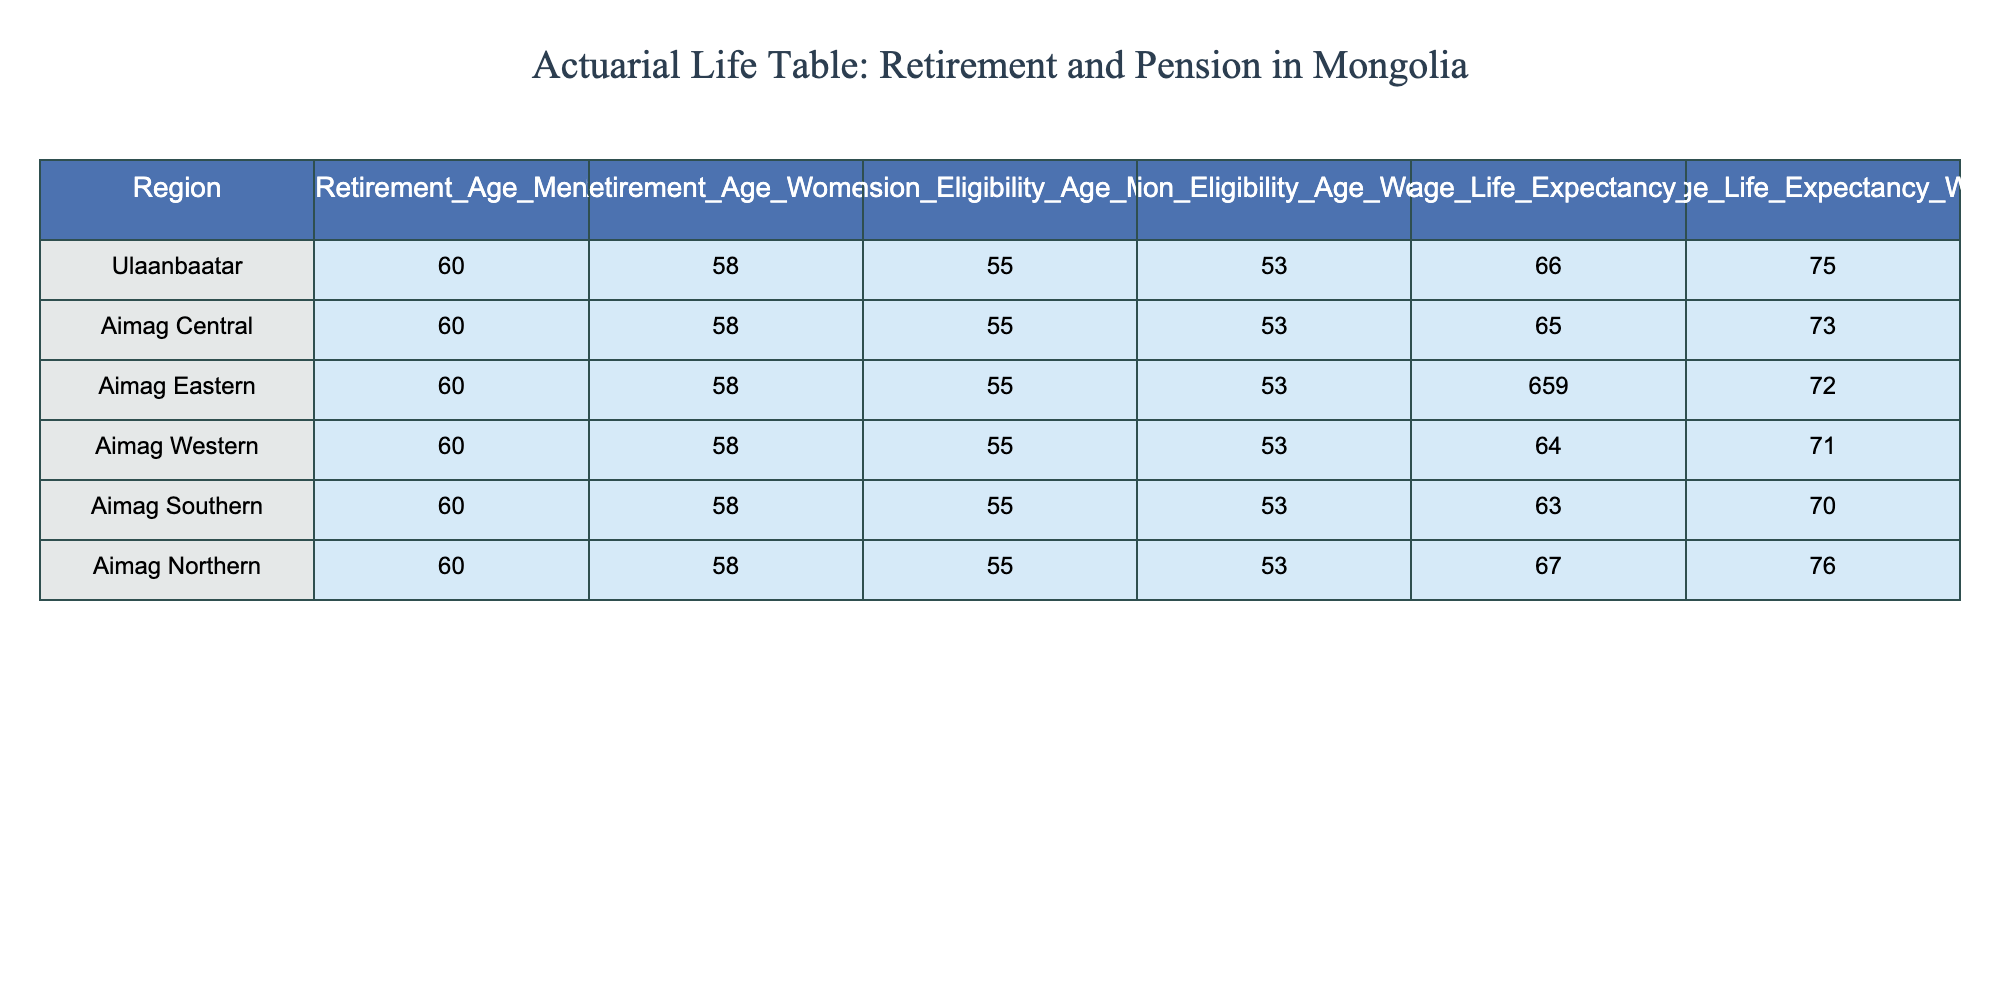What is the retirement age for men in Ulaanbaatar? According to the table, the retirement age for men in Ulaanbaatar is listed directly under the "Retirement_Age_Men" column, which is 60 years.
Answer: 60 What is the pension eligibility age for women in Aimag Central? The pension eligibility age for women in Aimag Central can be found in the "Pension_Eligibility_Age_Women" column for that region, which is 53 years.
Answer: 53 Is the average life expectancy for men in Aimag Northern greater than 70? The average life expectancy for men in Aimag Northern is found in the corresponding column, which shows 67 years. Since 67 is less than 70, the answer is no.
Answer: No What is the difference in retirement age between men and women in the Aimag Eastern region? The retirement age for men in Aimag Eastern is 60, and for women, it is 58. The difference is calculated as 60 - 58 = 2 years.
Answer: 2 Do all regions have the same retirement age for men? Upon reviewing the "Retirement_Age_Men" column for all regions, each has consistently listed 60 years, indicating yes, they are all the same.
Answer: Yes What is the average life expectancy for women across the regions listed? Summing the average life expectancies for women in all regions (75 + 73 + 72 + 71 + 70 + 76) gives us 437. Dividing by the number of regions (6) results in an average of 437/6 = 72.83.
Answer: 72.83 Which region has the highest average life expectancy for men? Checking the "Average_Life_Expectancy_Men" column, Aimag Northern has the highest value at 67 years.
Answer: Aimag Northern Is the pension eligibility age for men in Ulaanbaatar lower than that of women in Aimag Southern? In Ulaanbaatar, the pension eligibility age for men is 55, while in Aimag Southern, it is 53 for women. Because 55 is greater than 53, the answer is no.
Answer: No 